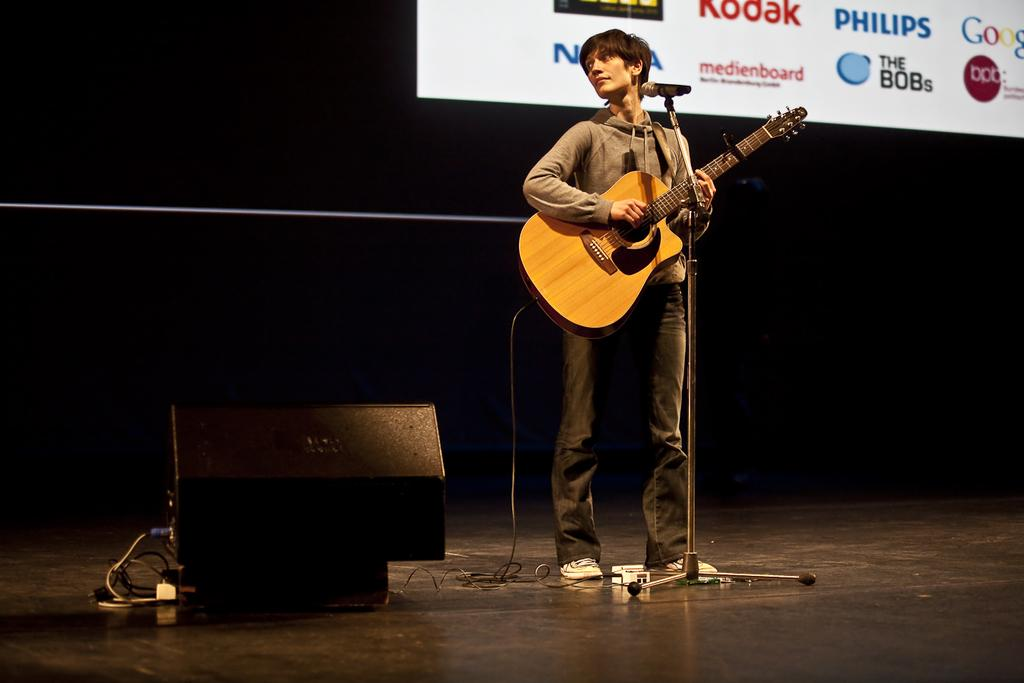What is the main subject of the image? There is a person in the image. What is the person doing in the image? The person is standing and holding a guitar in his hands. What object is in front of the person? There is a microphone in front of the person. What can be seen in the background of the image? There is a screen in the background of the image. Is the person teaching a class in the image? There is no indication in the image that the person is teaching a class. Can you see any snow in the image? There is no snow present in the image. 